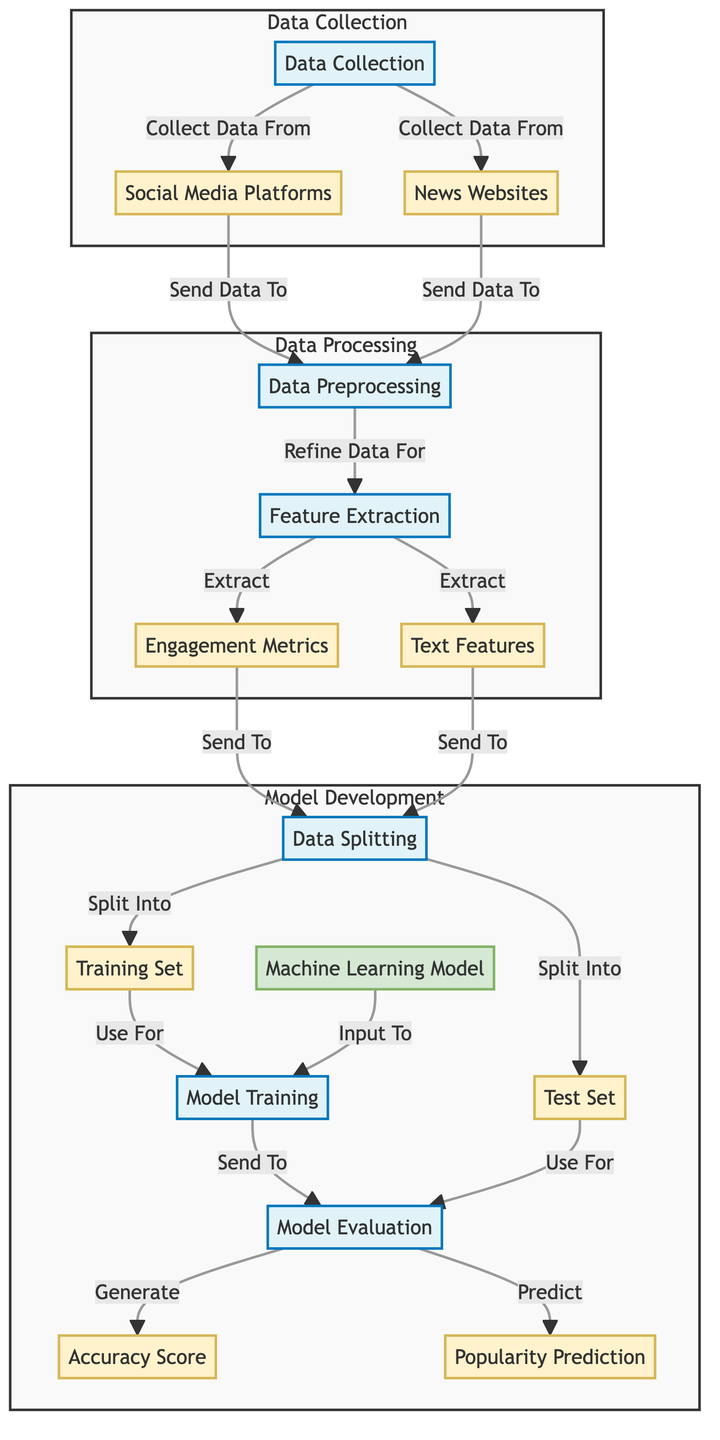What's the first step in the process? The process starts with the "Data Collection" step, which is the first node in the diagram. It collects data from both social media platforms and news websites.
Answer: Data Collection How many subgraphs are present in the diagram? There are three subgraphs in the diagram: "Data Collection," "Data Processing," and "Model Development." Each subgraph contains several interconnected nodes related to its process.
Answer: Three What types of data are collected in the Data Collection phase? In the Data Collection phase, data is collected from two types: social media platforms and news websites, which are both distinctly labeled as data nodes.
Answer: Social Media Platforms and News Websites Which step processes the collected data? The step that processes the collected data is "Data Preprocessing," which follows after the data is collected from social media platforms and news websites.
Answer: Data Preprocessing What does the "Model Evaluation" step generate? The "Model Evaluation" step generates two outputs: an accuracy score and a popularity prediction. It evaluates the trained model's performance on the test set.
Answer: Accuracy Score and Popularity Prediction How many data nodes are associated with the "Feature Extraction"? Two data nodes are associated with "Feature Extraction": "Engagement Metrics" and "Text Features." These are the outputs extracted from the preprocessed data.
Answer: Two Which nodes feed into the "Model Training" step? The nodes that feed into the "Model Training" step are the training set and the machine learning model, both of which are required for training.
Answer: Training Set and Machine Learning Model What is the purpose of the "Data Splitting" step? The purpose of the "Data Splitting" step is to divide the processed data into training and test sets, so that different sets can be used for training and evaluating the model effectively.
Answer: Split into Training Set and Test Set How is the data sent to the "Feature Extraction" step? The data is sent to the "Feature Extraction" step from the "Data Preprocessing" step, which prepares the refined data for the extraction of meaningful features.
Answer: From Data Preprocessing 